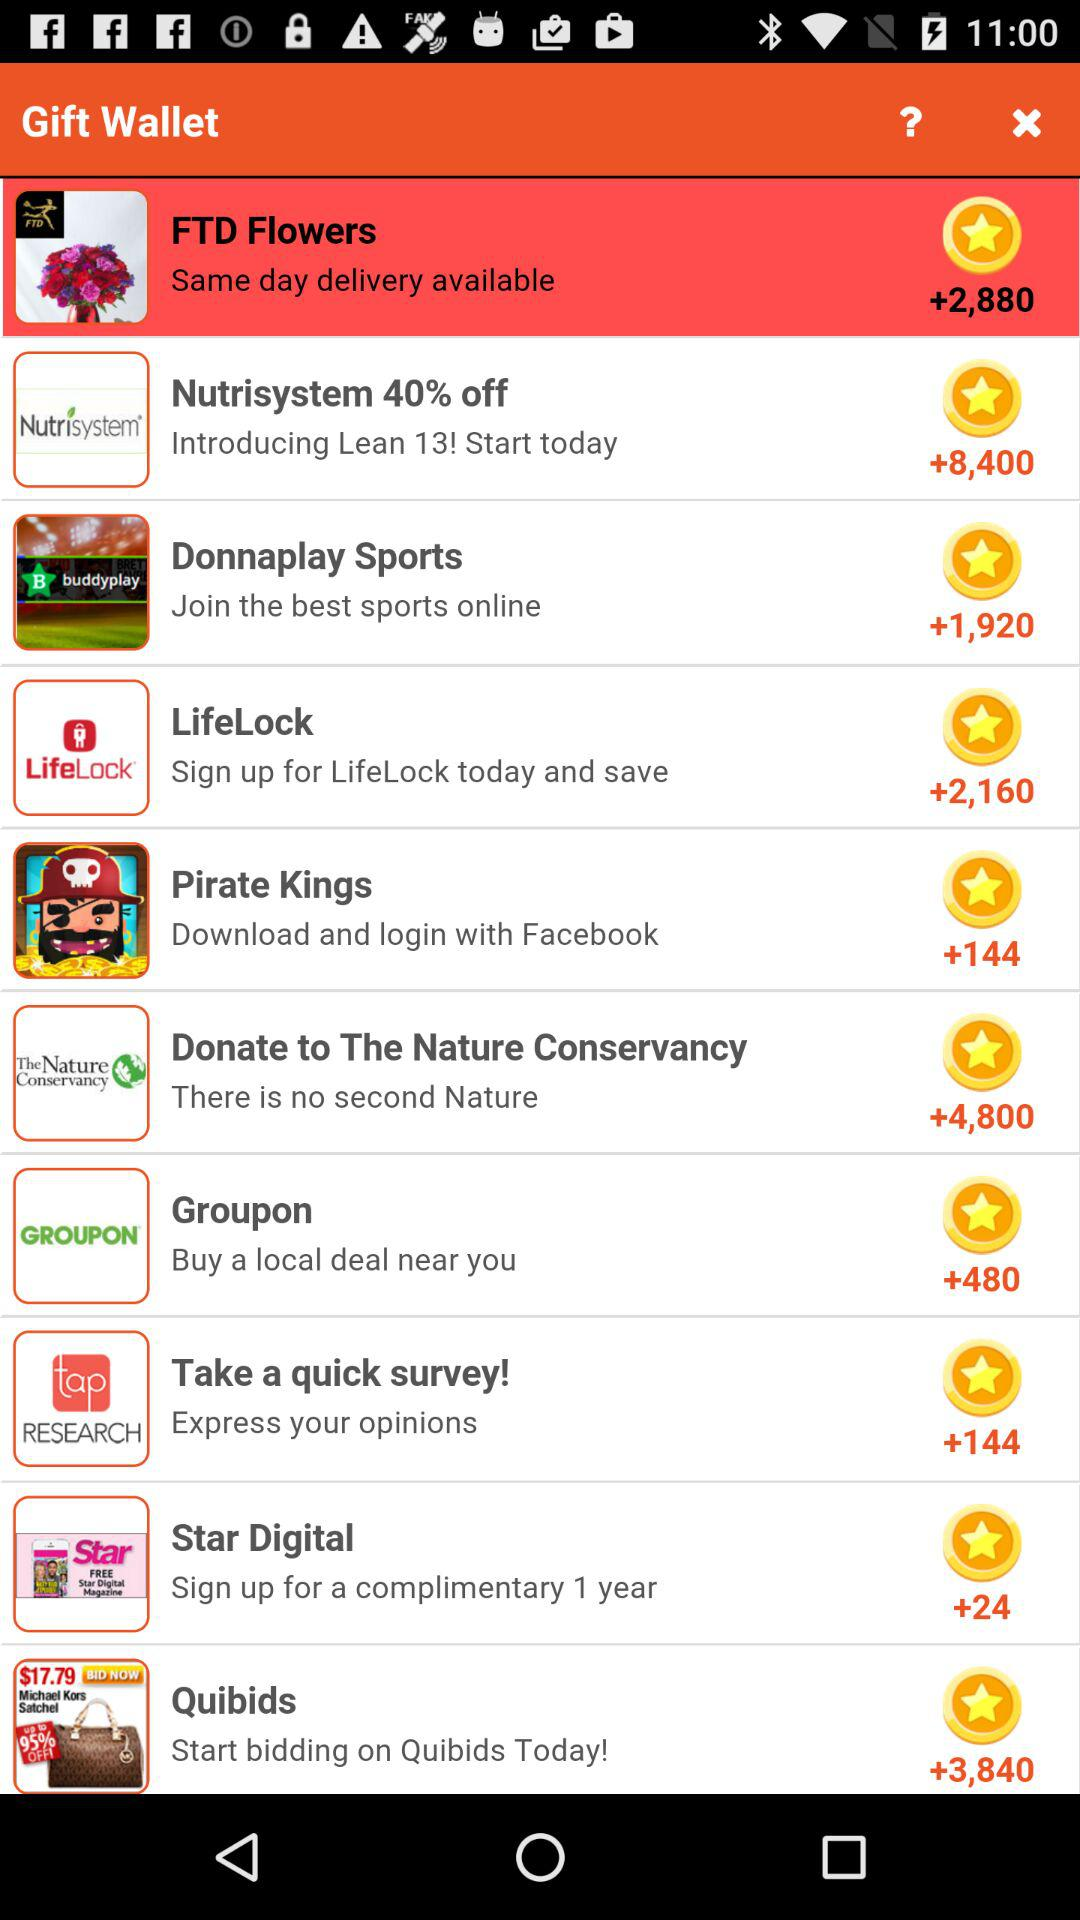How many points are there for a Groupon gift? There are +480 points. 